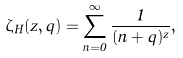<formula> <loc_0><loc_0><loc_500><loc_500>\zeta _ { H } ( z , q ) = \sum _ { n = 0 } ^ { \infty } \frac { 1 } { ( n + q ) ^ { z } } ,</formula> 